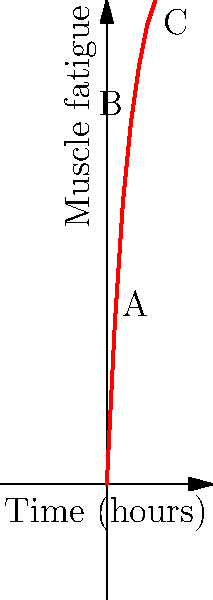The graph shows the muscle fatigue experienced by an artist while creating a large-scale political mural over time. Given the ergonomic challenges of this work, which point on the curve represents the optimal time to take a break to prevent excessive strain? To determine the optimal time for a break, we need to analyze the curve of muscle fatigue over time:

1. The curve shows a rapid increase in muscle fatigue during the first 2-3 hours (points A to B).
2. After point B (3 hours), the rate of increase in fatigue starts to slow down.
3. However, the fatigue continues to accumulate, albeit at a slower rate.
4. The optimal time to take a break is before the fatigue level becomes too high, but after the initial rapid increase.
5. Point B (3 hours) represents this optimal point because:
   a. It's after the initial rapid fatigue increase.
   b. It's before the cumulative fatigue becomes excessive.
   c. Taking a break at this point can help prevent the gradual fatigue buildup seen in the latter part of the curve.
6. Waiting until point C (6 hours) would allow too much fatigue to accumulate, potentially leading to strain or injury.

Therefore, point B, occurring at 3 hours, represents the optimal time to take a break.
Answer: B 